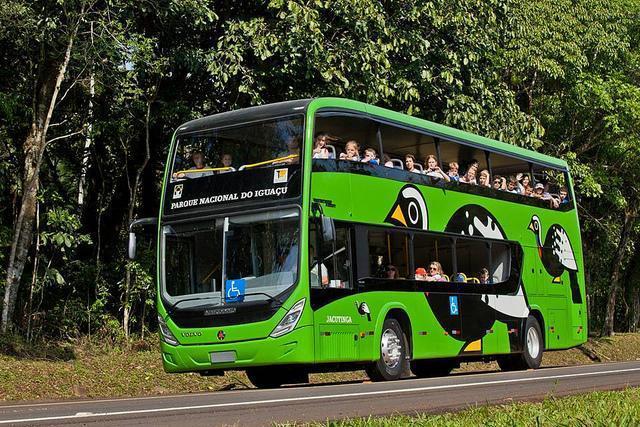How many decks does this bus have?
Give a very brief answer. 2. How many buses are in the photo?
Give a very brief answer. 1. How many birds can be seen?
Give a very brief answer. 2. How many dogs are looking at the camers?
Give a very brief answer. 0. 